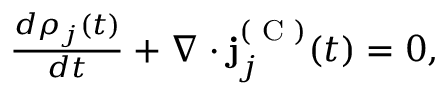Convert formula to latex. <formula><loc_0><loc_0><loc_500><loc_500>\begin{array} { r } { \frac { d \rho _ { j } ( t ) } { d t } + \nabla \cdot j _ { j } ^ { ( C ) } ( t ) = 0 , } \end{array}</formula> 